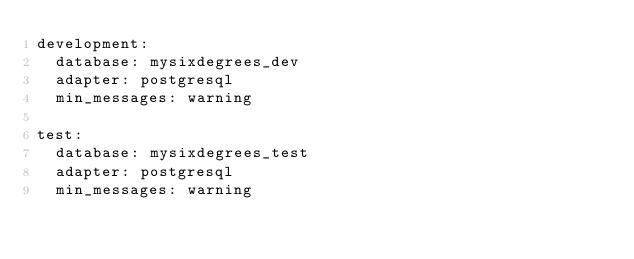<code> <loc_0><loc_0><loc_500><loc_500><_YAML_>development:
  database: mysixdegrees_dev
  adapter: postgresql
  min_messages: warning

test:
  database: mysixdegrees_test
  adapter: postgresql
  min_messages: warning

</code> 